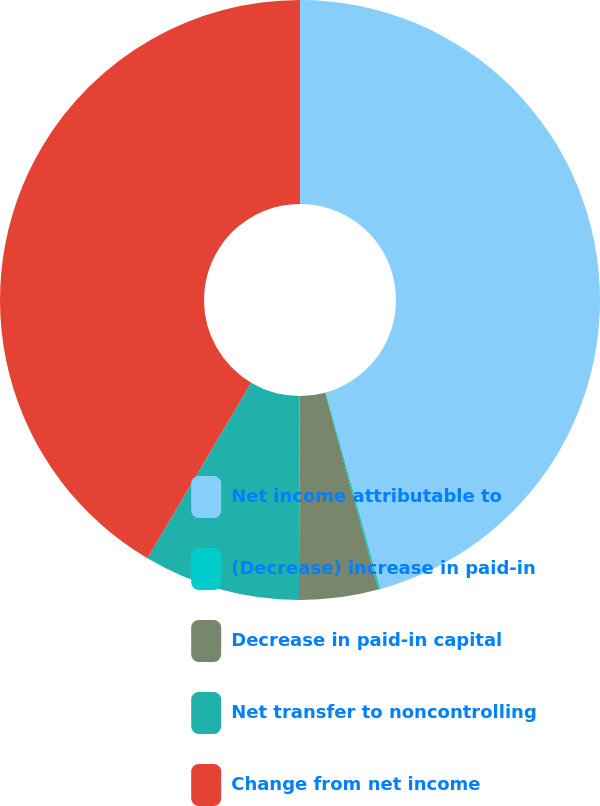Convert chart. <chart><loc_0><loc_0><loc_500><loc_500><pie_chart><fcel>Net income attributable to<fcel>(Decrease) increase in paid-in<fcel>Decrease in paid-in capital<fcel>Net transfer to noncontrolling<fcel>Change from net income<nl><fcel>45.69%<fcel>0.1%<fcel>4.27%<fcel>8.44%<fcel>41.51%<nl></chart> 